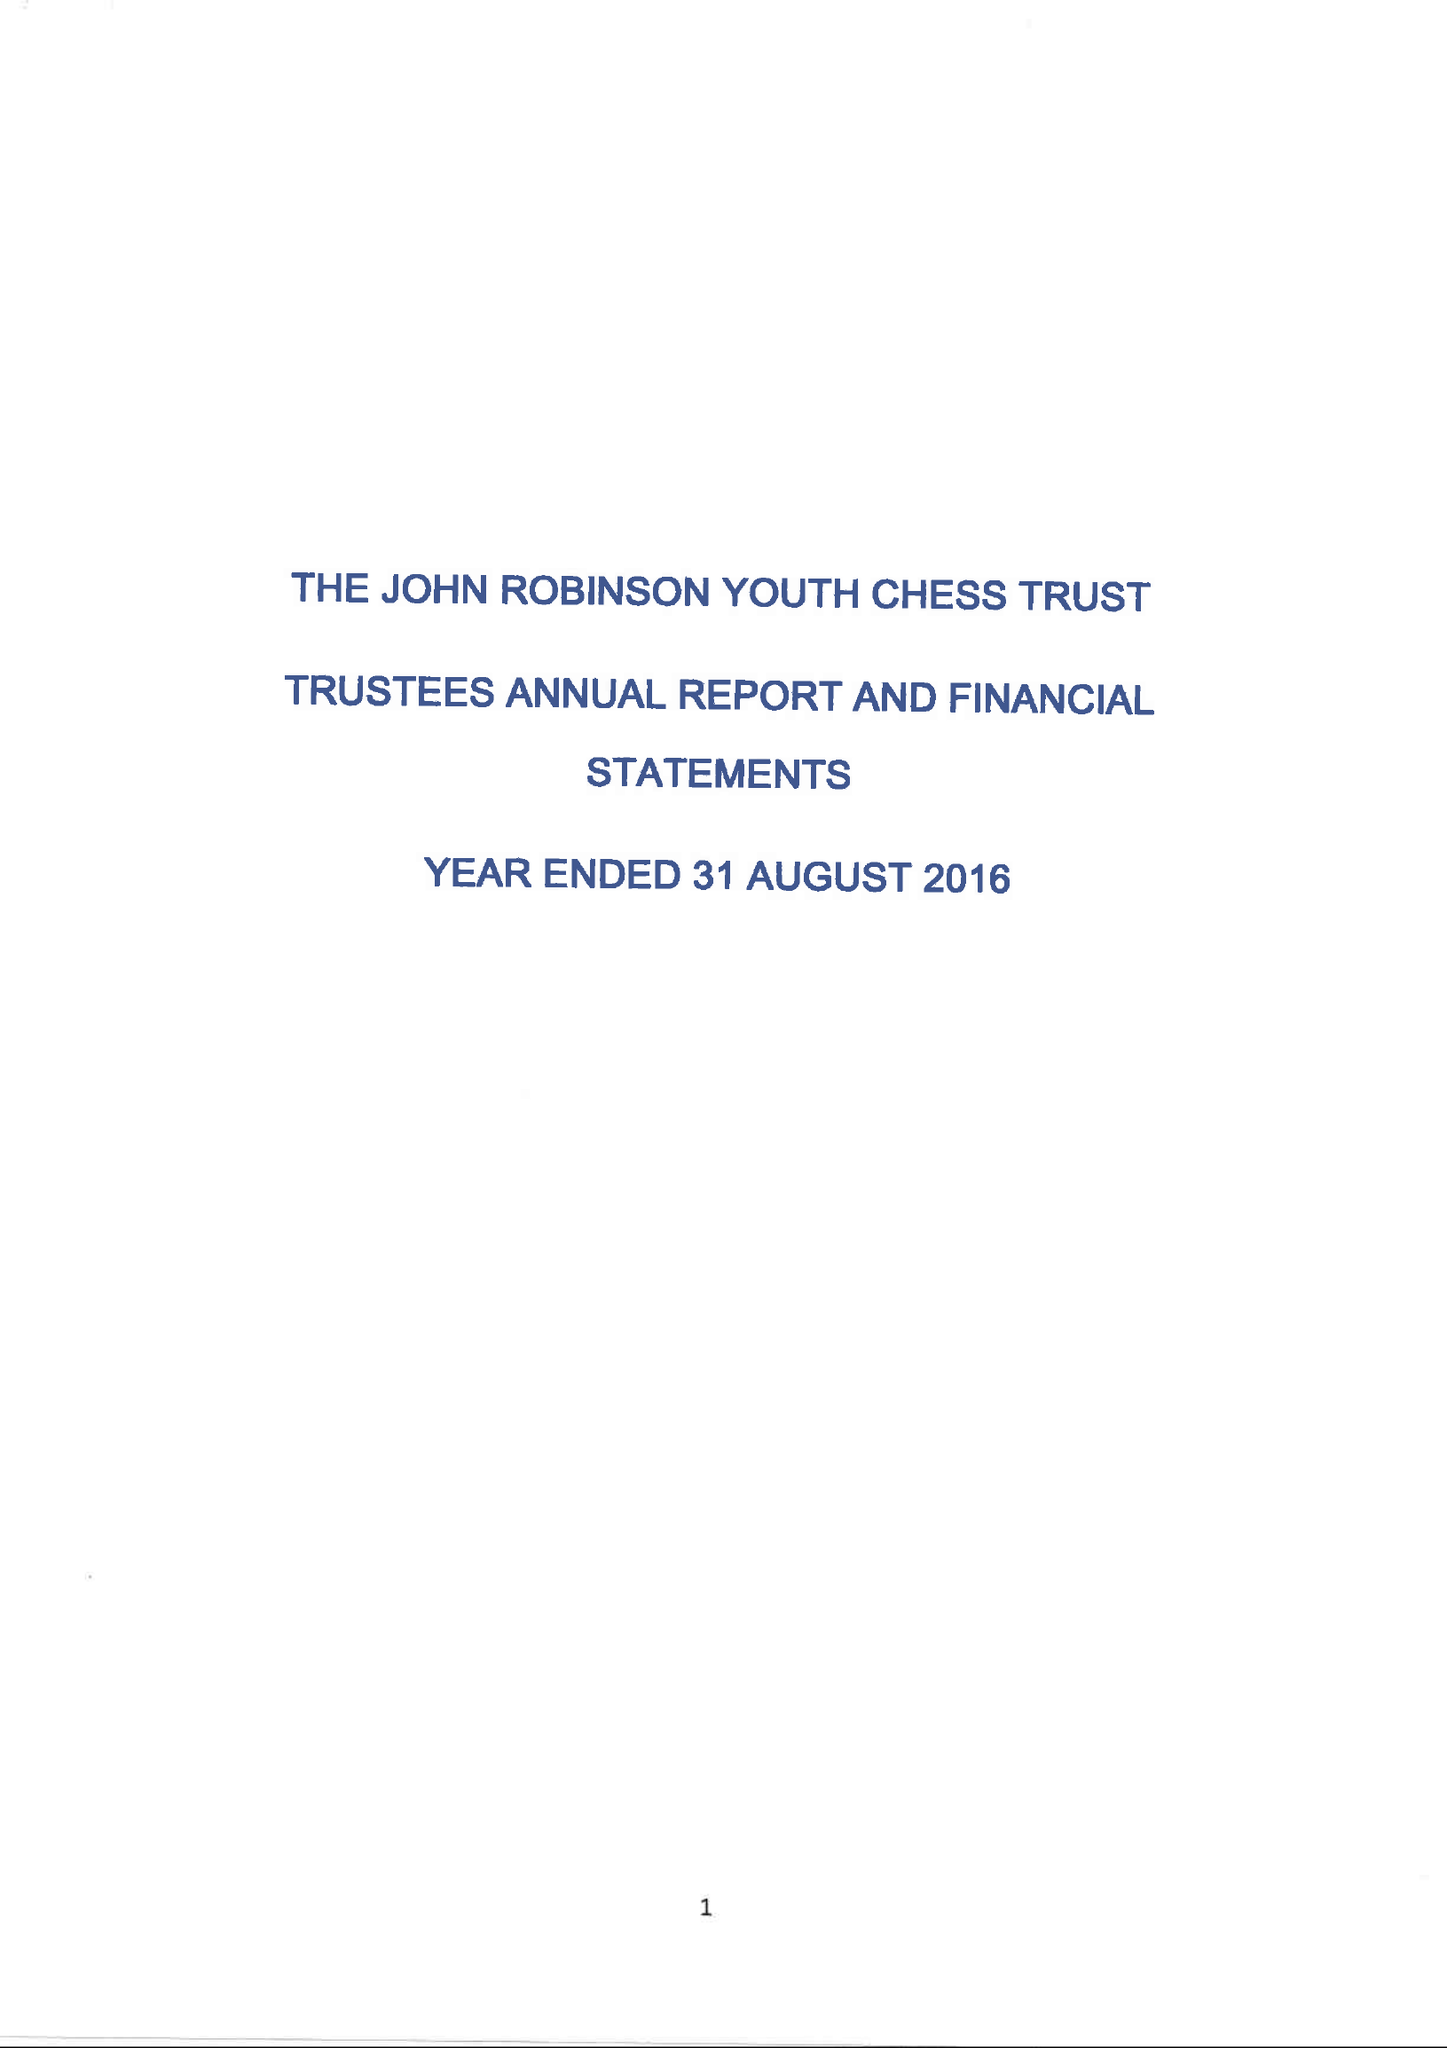What is the value for the report_date?
Answer the question using a single word or phrase. 2016-08-31 